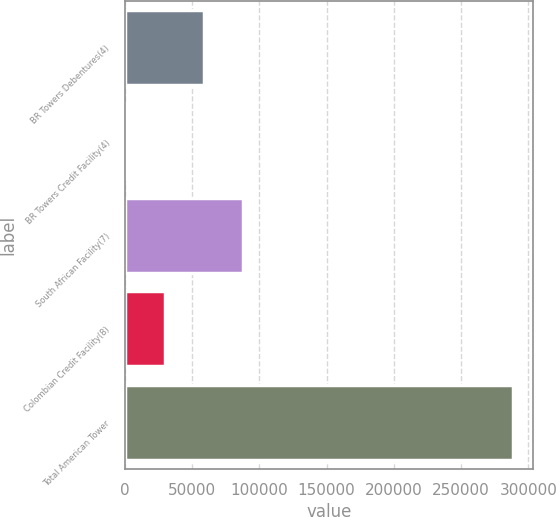<chart> <loc_0><loc_0><loc_500><loc_500><bar_chart><fcel>BR Towers Debentures(4)<fcel>BR Towers Credit Facility(4)<fcel>South African Facility(7)<fcel>Colombian Credit Facility(8)<fcel>Total American Tower<nl><fcel>58720.4<fcel>1198<fcel>87481.6<fcel>29959.2<fcel>288810<nl></chart> 